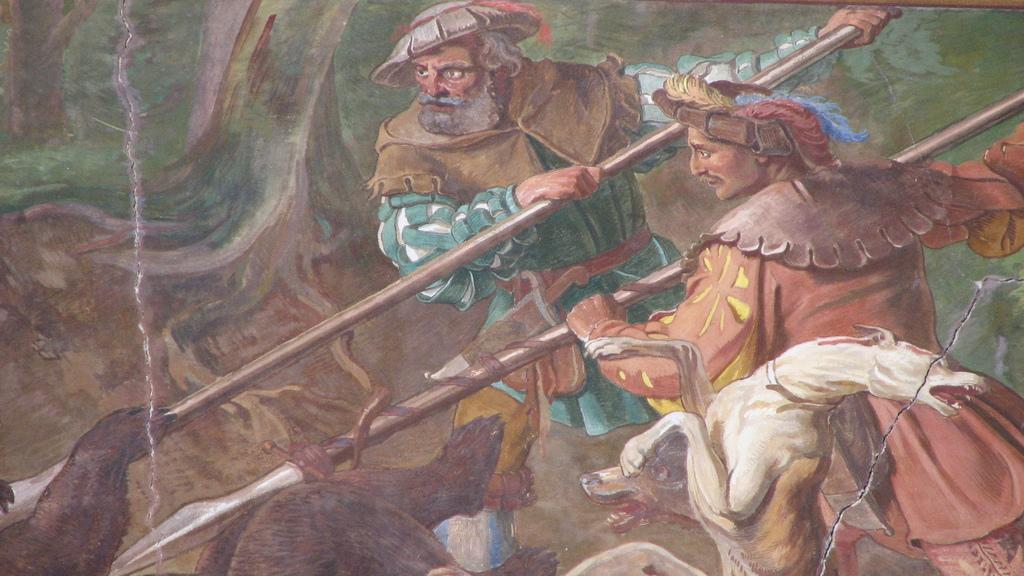How would you summarize this image in a sentence or two? The picture consists of a painting. In the center of the pictures there are two men holding spears. At the bottom there is a dog and there are two other animals. In the background there is greenery. In the center towards left there are roots and soil. 